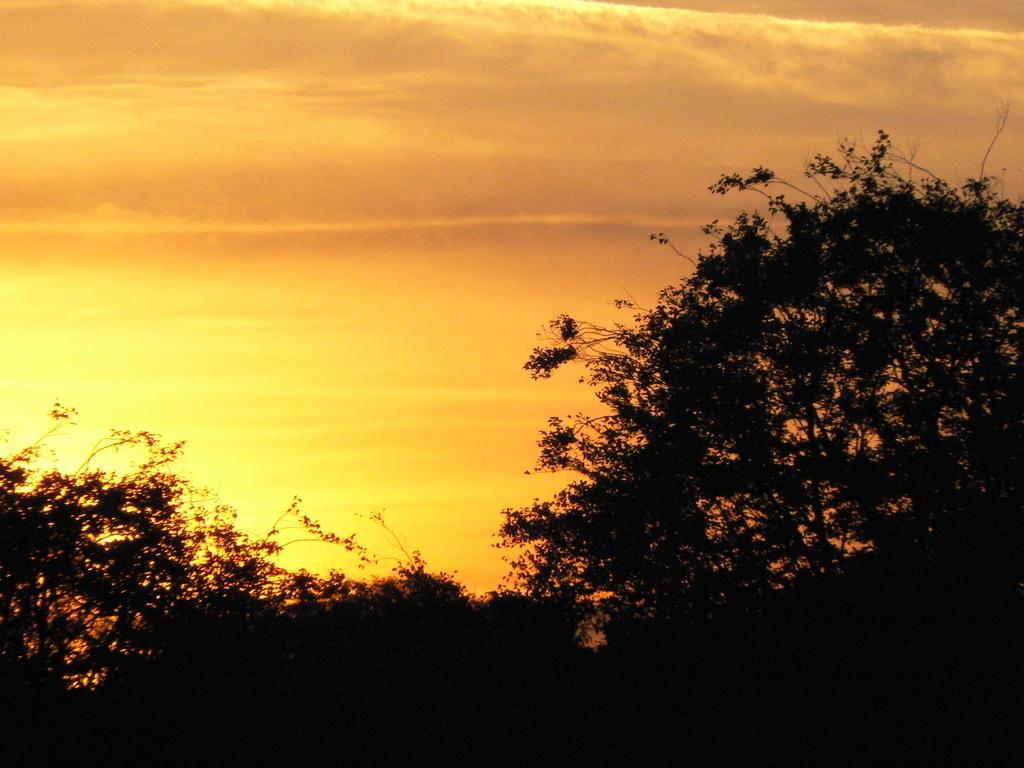What type of vegetation can be seen in the image? There are trees in the image. What part of the natural environment is visible in the image? The sky is visible in the image. What type of shelf can be seen in the image? There is no shelf present in the image. What is the wind doing in the image? There is no mention of wind in the image, so it cannot be determined what the wind is doing. 